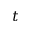<formula> <loc_0><loc_0><loc_500><loc_500>t</formula> 